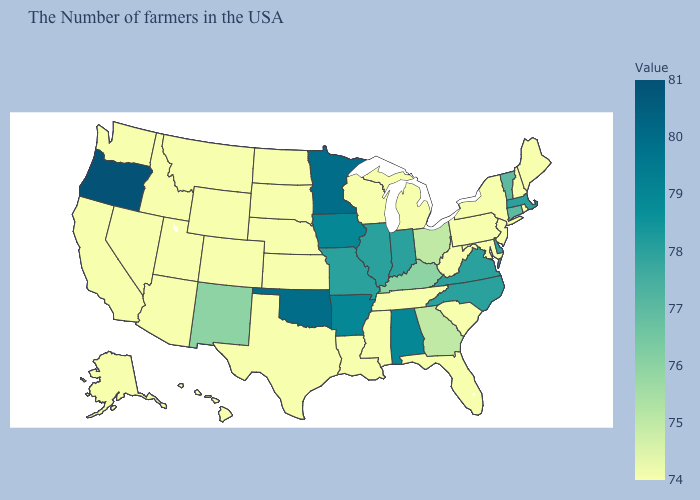Which states have the highest value in the USA?
Be succinct. Oregon. Does the map have missing data?
Write a very short answer. No. Among the states that border Mississippi , does Alabama have the highest value?
Write a very short answer. Yes. Which states have the highest value in the USA?
Answer briefly. Oregon. Is the legend a continuous bar?
Concise answer only. Yes. Does Maine have the highest value in the Northeast?
Keep it brief. No. 